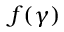<formula> <loc_0><loc_0><loc_500><loc_500>f ( \gamma )</formula> 